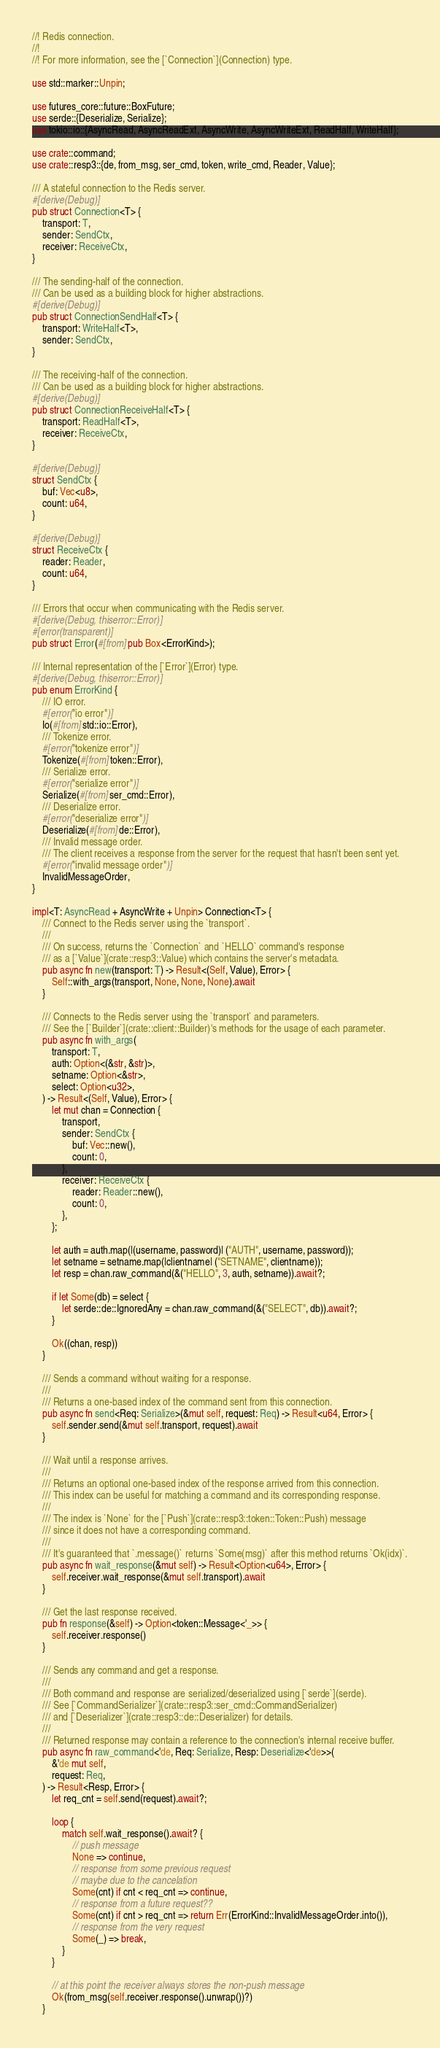Convert code to text. <code><loc_0><loc_0><loc_500><loc_500><_Rust_>//! Redis connection.
//!
//! For more information, see the [`Connection`](Connection) type.

use std::marker::Unpin;

use futures_core::future::BoxFuture;
use serde::{Deserialize, Serialize};
use tokio::io::{AsyncRead, AsyncReadExt, AsyncWrite, AsyncWriteExt, ReadHalf, WriteHalf};

use crate::command;
use crate::resp3::{de, from_msg, ser_cmd, token, write_cmd, Reader, Value};

/// A stateful connection to the Redis server.
#[derive(Debug)]
pub struct Connection<T> {
    transport: T,
    sender: SendCtx,
    receiver: ReceiveCtx,
}

/// The sending-half of the connection.
/// Can be used as a building block for higher abstractions.
#[derive(Debug)]
pub struct ConnectionSendHalf<T> {
    transport: WriteHalf<T>,
    sender: SendCtx,
}

/// The receiving-half of the connection.
/// Can be used as a building block for higher abstractions.
#[derive(Debug)]
pub struct ConnectionReceiveHalf<T> {
    transport: ReadHalf<T>,
    receiver: ReceiveCtx,
}

#[derive(Debug)]
struct SendCtx {
    buf: Vec<u8>,
    count: u64,
}

#[derive(Debug)]
struct ReceiveCtx {
    reader: Reader,
    count: u64,
}

/// Errors that occur when communicating with the Redis server.
#[derive(Debug, thiserror::Error)]
#[error(transparent)]
pub struct Error(#[from] pub Box<ErrorKind>);

/// Internal representation of the [`Error`](Error) type.
#[derive(Debug, thiserror::Error)]
pub enum ErrorKind {
    /// IO error.
    #[error("io error")]
    Io(#[from] std::io::Error),
    /// Tokenize error.
    #[error("tokenize error")]
    Tokenize(#[from] token::Error),
    /// Serialize error.
    #[error("serialize error")]
    Serialize(#[from] ser_cmd::Error),
    /// Deserialize error.
    #[error("deserialize error")]
    Deserialize(#[from] de::Error),
    /// Invalid message order.
    /// The client receives a response from the server for the request that hasn't been sent yet.
    #[error("invalid message order")]
    InvalidMessageOrder,
}

impl<T: AsyncRead + AsyncWrite + Unpin> Connection<T> {
    /// Connect to the Redis server using the `transport`.
    ///
    /// On success, returns the `Connection` and `HELLO` command's response
    /// as a [`Value`](crate::resp3::Value) which contains the server's metadata.
    pub async fn new(transport: T) -> Result<(Self, Value), Error> {
        Self::with_args(transport, None, None, None).await
    }

    /// Connects to the Redis server using the `transport` and parameters.
    /// See the [`Builder`](crate::client::Builder)'s methods for the usage of each parameter.
    pub async fn with_args(
        transport: T,
        auth: Option<(&str, &str)>,
        setname: Option<&str>,
        select: Option<u32>,
    ) -> Result<(Self, Value), Error> {
        let mut chan = Connection {
            transport,
            sender: SendCtx {
                buf: Vec::new(),
                count: 0,
            },
            receiver: ReceiveCtx {
                reader: Reader::new(),
                count: 0,
            },
        };

        let auth = auth.map(|(username, password)| ("AUTH", username, password));
        let setname = setname.map(|clientname| ("SETNAME", clientname));
        let resp = chan.raw_command(&("HELLO", 3, auth, setname)).await?;

        if let Some(db) = select {
            let serde::de::IgnoredAny = chan.raw_command(&("SELECT", db)).await?;
        }

        Ok((chan, resp))
    }

    /// Sends a command without waiting for a response.
    ///
    /// Returns a one-based index of the command sent from this connection.
    pub async fn send<Req: Serialize>(&mut self, request: Req) -> Result<u64, Error> {
        self.sender.send(&mut self.transport, request).await
    }

    /// Wait until a response arrives.
    ///
    /// Returns an optional one-based index of the response arrived from this connection.
    /// This index can be useful for matching a command and its corresponding response.
    ///
    /// The index is `None` for the [`Push`](crate::resp3::token::Token::Push) message
    /// since it does not have a corresponding command.
    ///
    /// It's guaranteed that `.message()` returns `Some(msg)` after this method returns `Ok(idx)`.
    pub async fn wait_response(&mut self) -> Result<Option<u64>, Error> {
        self.receiver.wait_response(&mut self.transport).await
    }

    /// Get the last response received.
    pub fn response(&self) -> Option<token::Message<'_>> {
        self.receiver.response()
    }

    /// Sends any command and get a response.
    ///
    /// Both command and response are serialized/deserialized using [`serde`](serde).
    /// See [`CommandSerializer`](crate::resp3::ser_cmd::CommandSerializer)
    /// and [`Deserializer`](crate::resp3::de::Deserializer) for details.
    ///
    /// Returned response may contain a reference to the connection's internal receive buffer.
    pub async fn raw_command<'de, Req: Serialize, Resp: Deserialize<'de>>(
        &'de mut self,
        request: Req,
    ) -> Result<Resp, Error> {
        let req_cnt = self.send(request).await?;

        loop {
            match self.wait_response().await? {
                // push message
                None => continue,
                // response from some previous request
                // maybe due to the cancelation
                Some(cnt) if cnt < req_cnt => continue,
                // response from a future request??
                Some(cnt) if cnt > req_cnt => return Err(ErrorKind::InvalidMessageOrder.into()),
                // response from the very request
                Some(_) => break,
            }
        }

        // at this point the receiver always stores the non-push message
        Ok(from_msg(self.receiver.response().unwrap())?)
    }
</code> 